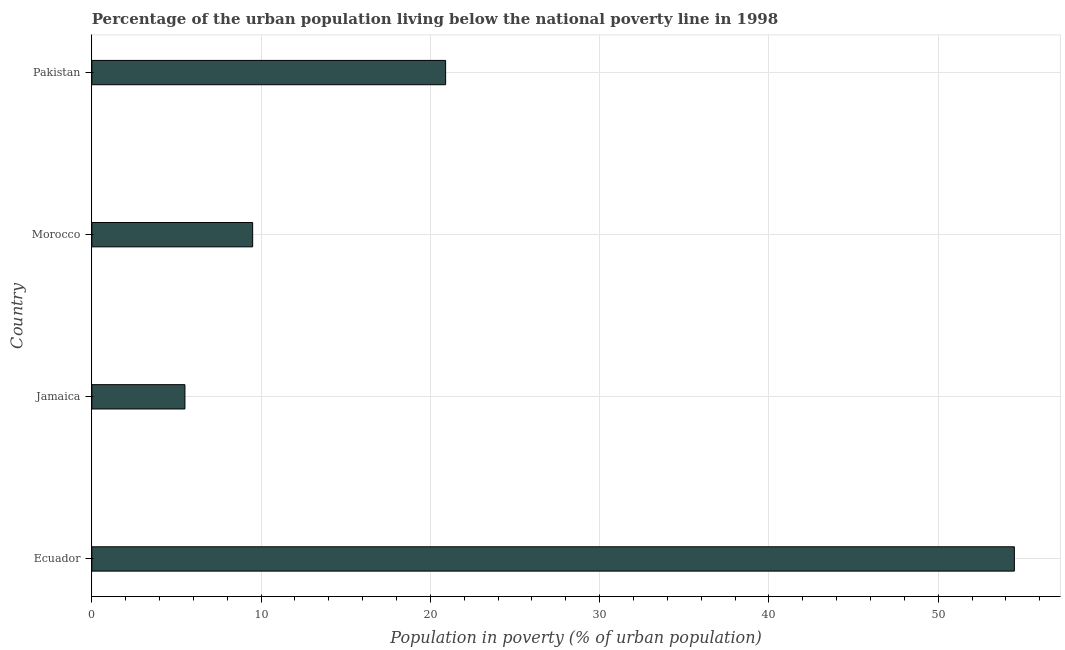Does the graph contain any zero values?
Give a very brief answer. No. Does the graph contain grids?
Provide a succinct answer. Yes. What is the title of the graph?
Provide a succinct answer. Percentage of the urban population living below the national poverty line in 1998. What is the label or title of the X-axis?
Offer a terse response. Population in poverty (% of urban population). Across all countries, what is the maximum percentage of urban population living below poverty line?
Offer a very short reply. 54.5. In which country was the percentage of urban population living below poverty line maximum?
Give a very brief answer. Ecuador. In which country was the percentage of urban population living below poverty line minimum?
Offer a terse response. Jamaica. What is the sum of the percentage of urban population living below poverty line?
Provide a short and direct response. 90.4. What is the difference between the percentage of urban population living below poverty line in Morocco and Pakistan?
Provide a succinct answer. -11.4. What is the average percentage of urban population living below poverty line per country?
Keep it short and to the point. 22.6. In how many countries, is the percentage of urban population living below poverty line greater than 14 %?
Give a very brief answer. 2. What is the ratio of the percentage of urban population living below poverty line in Jamaica to that in Pakistan?
Keep it short and to the point. 0.26. Is the percentage of urban population living below poverty line in Ecuador less than that in Pakistan?
Your answer should be very brief. No. Is the difference between the percentage of urban population living below poverty line in Morocco and Pakistan greater than the difference between any two countries?
Offer a terse response. No. What is the difference between the highest and the second highest percentage of urban population living below poverty line?
Provide a short and direct response. 33.6. What is the difference between the highest and the lowest percentage of urban population living below poverty line?
Provide a short and direct response. 49. Are all the bars in the graph horizontal?
Offer a very short reply. Yes. How many countries are there in the graph?
Offer a very short reply. 4. Are the values on the major ticks of X-axis written in scientific E-notation?
Make the answer very short. No. What is the Population in poverty (% of urban population) in Ecuador?
Give a very brief answer. 54.5. What is the Population in poverty (% of urban population) in Morocco?
Provide a succinct answer. 9.5. What is the Population in poverty (% of urban population) of Pakistan?
Keep it short and to the point. 20.9. What is the difference between the Population in poverty (% of urban population) in Ecuador and Jamaica?
Provide a short and direct response. 49. What is the difference between the Population in poverty (% of urban population) in Ecuador and Pakistan?
Give a very brief answer. 33.6. What is the difference between the Population in poverty (% of urban population) in Jamaica and Pakistan?
Your response must be concise. -15.4. What is the ratio of the Population in poverty (% of urban population) in Ecuador to that in Jamaica?
Offer a very short reply. 9.91. What is the ratio of the Population in poverty (% of urban population) in Ecuador to that in Morocco?
Give a very brief answer. 5.74. What is the ratio of the Population in poverty (% of urban population) in Ecuador to that in Pakistan?
Provide a succinct answer. 2.61. What is the ratio of the Population in poverty (% of urban population) in Jamaica to that in Morocco?
Your response must be concise. 0.58. What is the ratio of the Population in poverty (% of urban population) in Jamaica to that in Pakistan?
Keep it short and to the point. 0.26. What is the ratio of the Population in poverty (% of urban population) in Morocco to that in Pakistan?
Offer a very short reply. 0.46. 